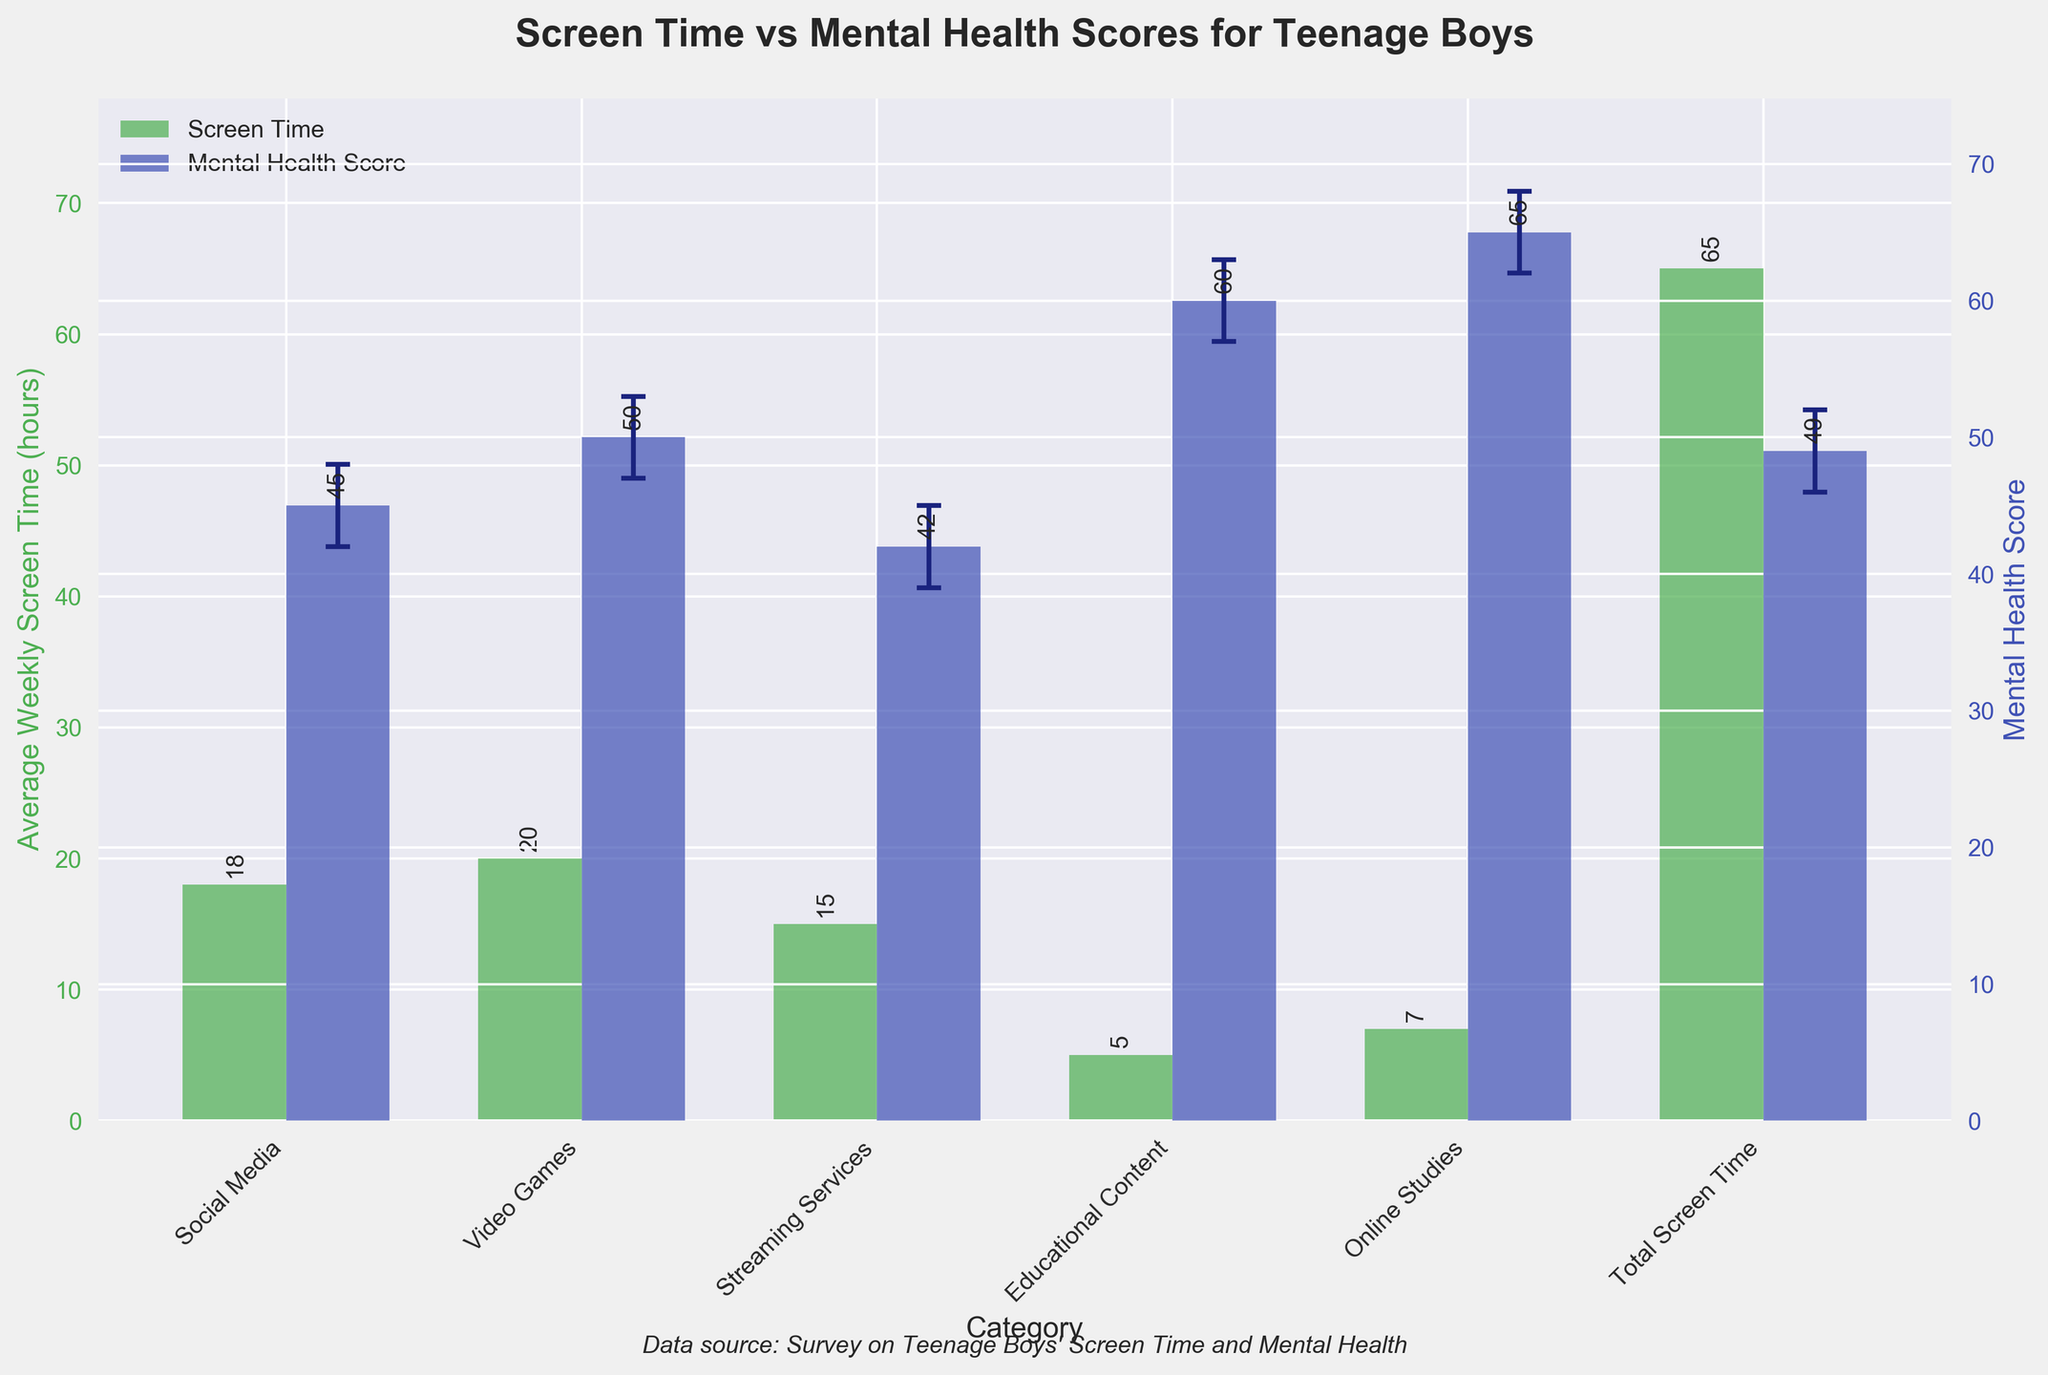What is the title of the figure? The title of the figure is written at the top of the chart.
Answer: Screen Time vs Mental Health Scores for Teenage Boys How many categories are being analyzed in the figure? Count the distinct bars or labels on the x-axis representing different categories.
Answer: 6 Which category has the highest average weekly screen time? Compare the heights of the green bars (representing screen time) across all categories.
Answer: Video Games What is the mental health score for Online Studies? Look for the blue bar corresponding to Online Studies and note its value.
Answer: 65 What is the confidence interval for mental health scores in the Social Media category? Check the error bars on the blue bar for Social Media, noting the lowest and highest points.
Answer: 42 to 48 What is the difference in average weekly screen time between Social Media and Streaming Services? Subtract the screen time value of Streaming Services from that of Social Media.
Answer: 3 hours Which category has the lowest mental health score? Compare the heights of the blue bars (mental health scores) across all categories and find the minimum.
Answer: Streaming Services Are there any categories with overlapping confidence intervals for mental health scores? Check the error bars for each category's mental health score to see if any intervals overlap.
Answer: Yes, Social Media and Video Games By how much does the mental health score for Educational Content exceed that for Social Media? Subtract the mental health score of Social Media from that of Educational Content.
Answer: 15 points Which category shows the largest discrepancy between the average weekly screen time and mental health scores? Compare the differences between the heights of green and blue bars for each category and identify the largest difference.
Answer: Online Studies 